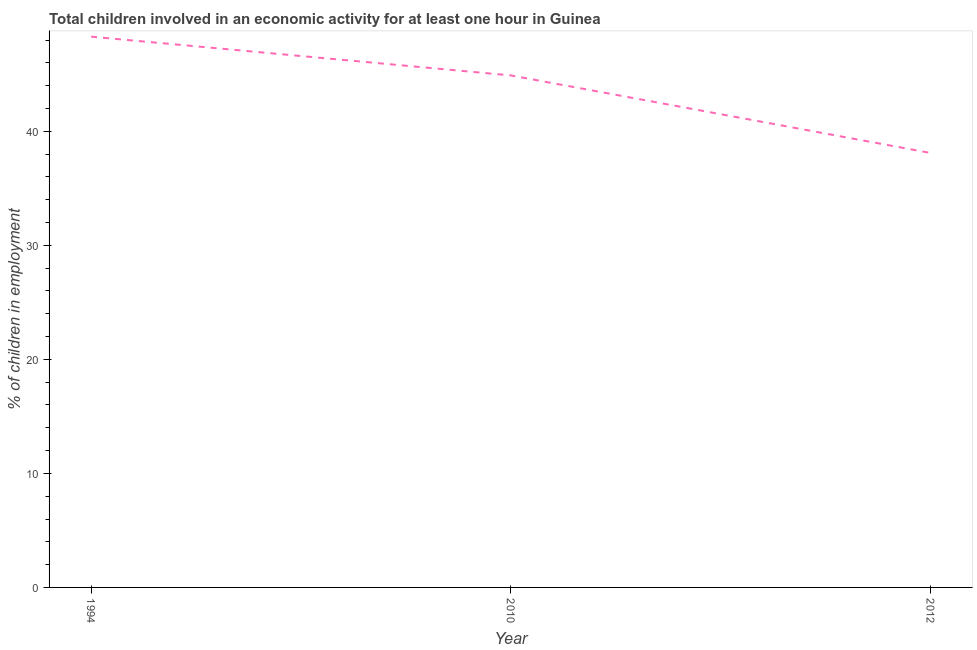What is the percentage of children in employment in 1994?
Your answer should be compact. 48.3. Across all years, what is the maximum percentage of children in employment?
Your answer should be very brief. 48.3. Across all years, what is the minimum percentage of children in employment?
Your answer should be very brief. 38.1. In which year was the percentage of children in employment maximum?
Give a very brief answer. 1994. In which year was the percentage of children in employment minimum?
Keep it short and to the point. 2012. What is the sum of the percentage of children in employment?
Keep it short and to the point. 131.3. What is the difference between the percentage of children in employment in 1994 and 2012?
Your answer should be very brief. 10.2. What is the average percentage of children in employment per year?
Provide a short and direct response. 43.77. What is the median percentage of children in employment?
Give a very brief answer. 44.9. Do a majority of the years between 2010 and 1994 (inclusive) have percentage of children in employment greater than 36 %?
Make the answer very short. No. What is the ratio of the percentage of children in employment in 1994 to that in 2012?
Ensure brevity in your answer.  1.27. Is the percentage of children in employment in 2010 less than that in 2012?
Offer a very short reply. No. Is the difference between the percentage of children in employment in 1994 and 2012 greater than the difference between any two years?
Ensure brevity in your answer.  Yes. What is the difference between the highest and the second highest percentage of children in employment?
Keep it short and to the point. 3.4. Is the sum of the percentage of children in employment in 1994 and 2012 greater than the maximum percentage of children in employment across all years?
Offer a terse response. Yes. What is the difference between the highest and the lowest percentage of children in employment?
Offer a terse response. 10.2. In how many years, is the percentage of children in employment greater than the average percentage of children in employment taken over all years?
Provide a short and direct response. 2. How many lines are there?
Your answer should be very brief. 1. How many years are there in the graph?
Ensure brevity in your answer.  3. Does the graph contain any zero values?
Offer a terse response. No. Does the graph contain grids?
Provide a short and direct response. No. What is the title of the graph?
Your answer should be very brief. Total children involved in an economic activity for at least one hour in Guinea. What is the label or title of the Y-axis?
Provide a short and direct response. % of children in employment. What is the % of children in employment in 1994?
Provide a short and direct response. 48.3. What is the % of children in employment of 2010?
Provide a succinct answer. 44.9. What is the % of children in employment in 2012?
Make the answer very short. 38.1. What is the difference between the % of children in employment in 1994 and 2010?
Give a very brief answer. 3.4. What is the difference between the % of children in employment in 2010 and 2012?
Provide a short and direct response. 6.8. What is the ratio of the % of children in employment in 1994 to that in 2010?
Make the answer very short. 1.08. What is the ratio of the % of children in employment in 1994 to that in 2012?
Provide a short and direct response. 1.27. What is the ratio of the % of children in employment in 2010 to that in 2012?
Your answer should be very brief. 1.18. 